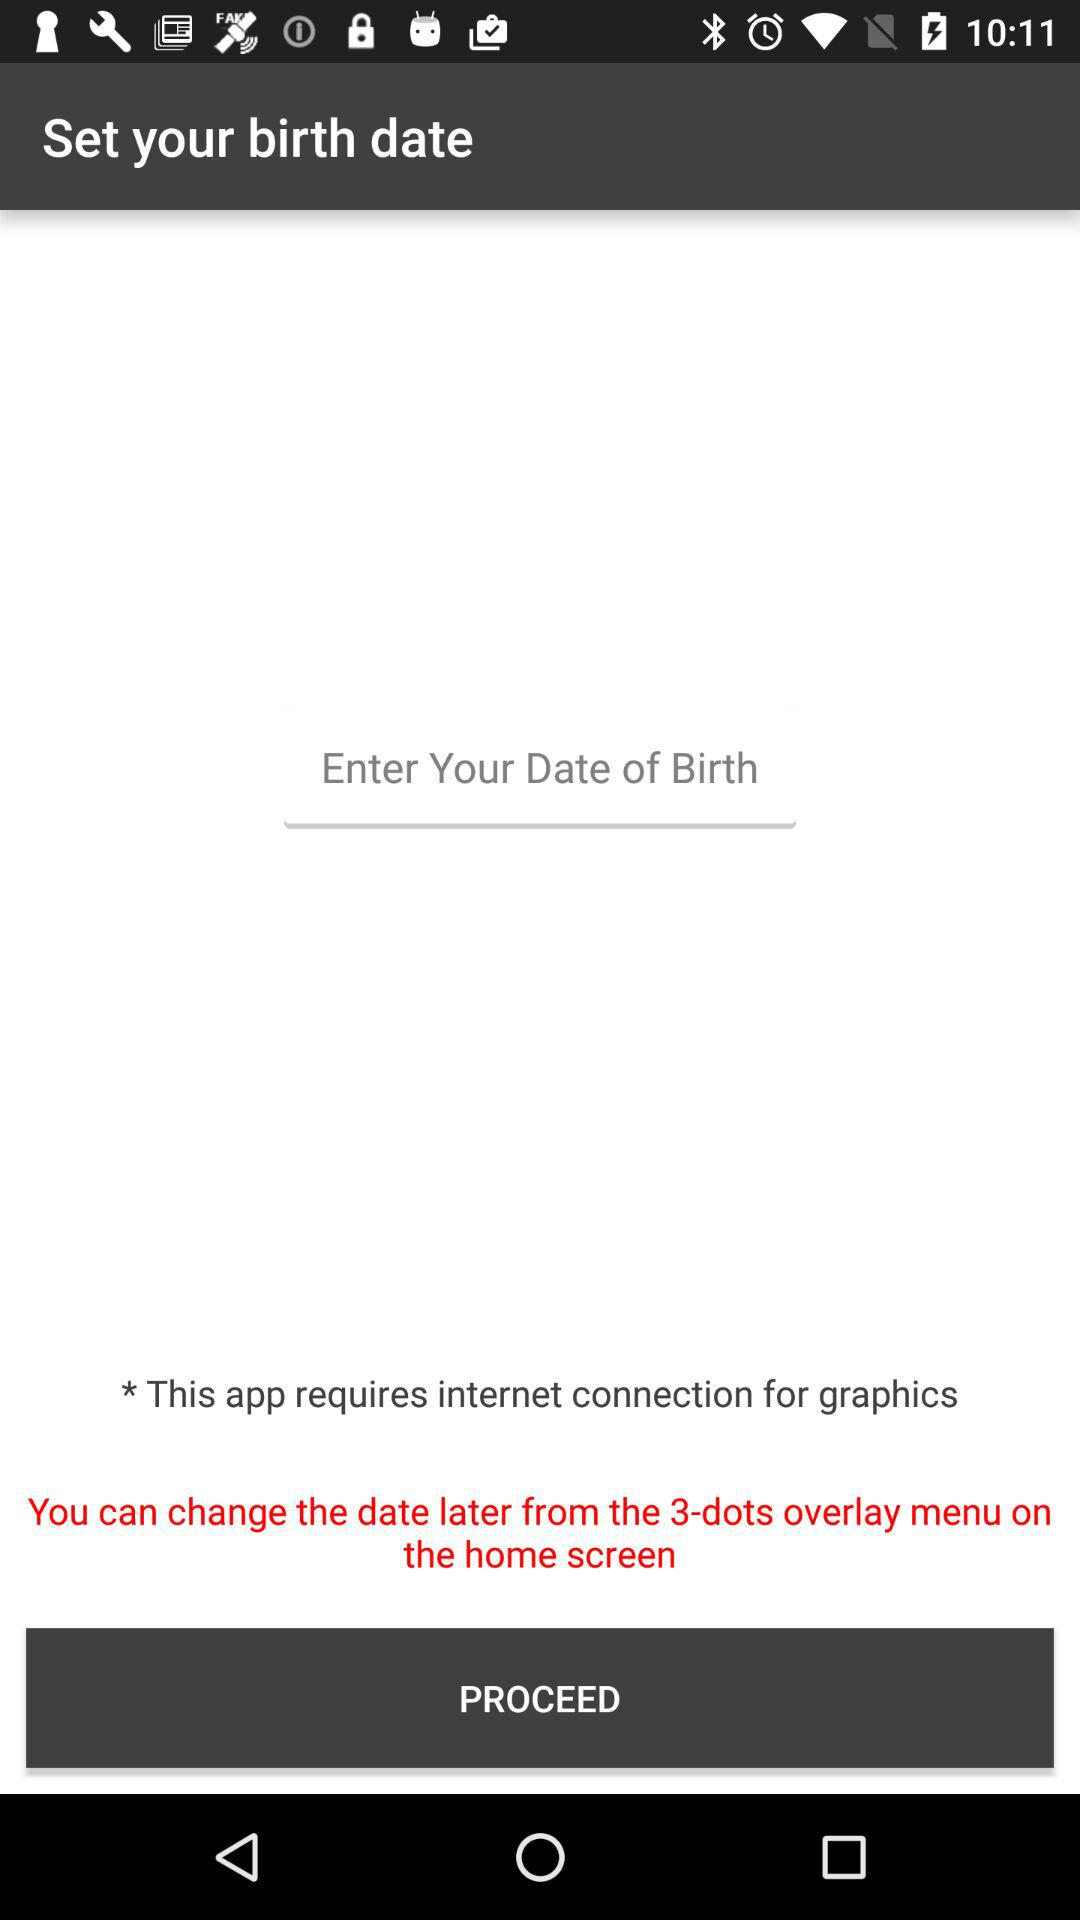Which date is selected for the birthday?
When the provided information is insufficient, respond with <no answer>. <no answer> 